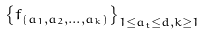Convert formula to latex. <formula><loc_0><loc_0><loc_500><loc_500>\left \{ f _ { ( a _ { 1 } , a _ { 2 } , \dots , a _ { k } ) } \right \} _ { 1 \leq a _ { t } \leq d , k \geq 1 }</formula> 